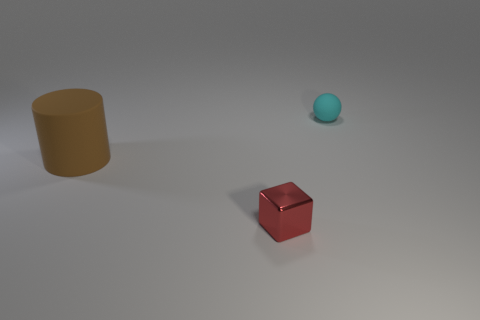Add 1 purple things. How many objects exist? 4 Subtract all blocks. How many objects are left? 2 Subtract all tiny blocks. Subtract all brown metallic things. How many objects are left? 2 Add 1 small red metal blocks. How many small red metal blocks are left? 2 Add 3 large gray cylinders. How many large gray cylinders exist? 3 Subtract 0 gray cylinders. How many objects are left? 3 